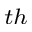Convert formula to latex. <formula><loc_0><loc_0><loc_500><loc_500>^ { t h }</formula> 